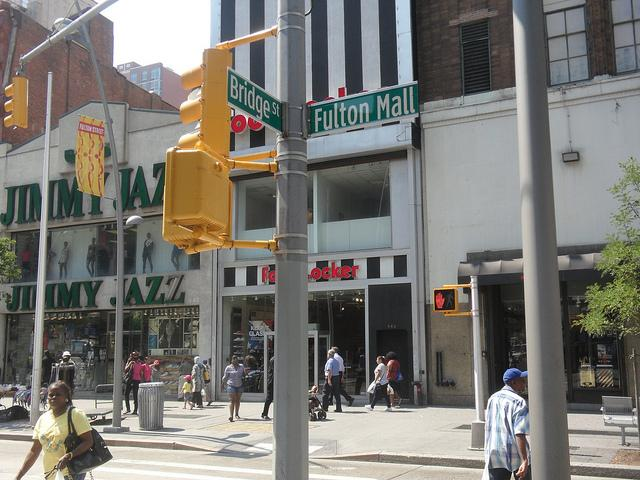Where should you go from the traffic light if you want to go to Fulton Mall? left 